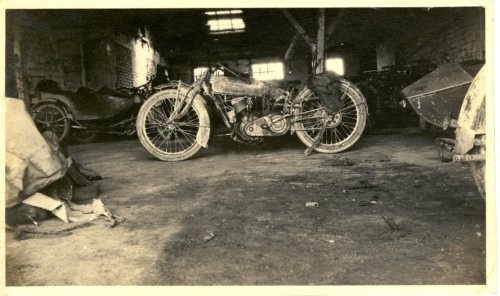Describe the objects in this image and their specific colors. I can see a motorcycle in khaki, black, gray, and tan tones in this image. 